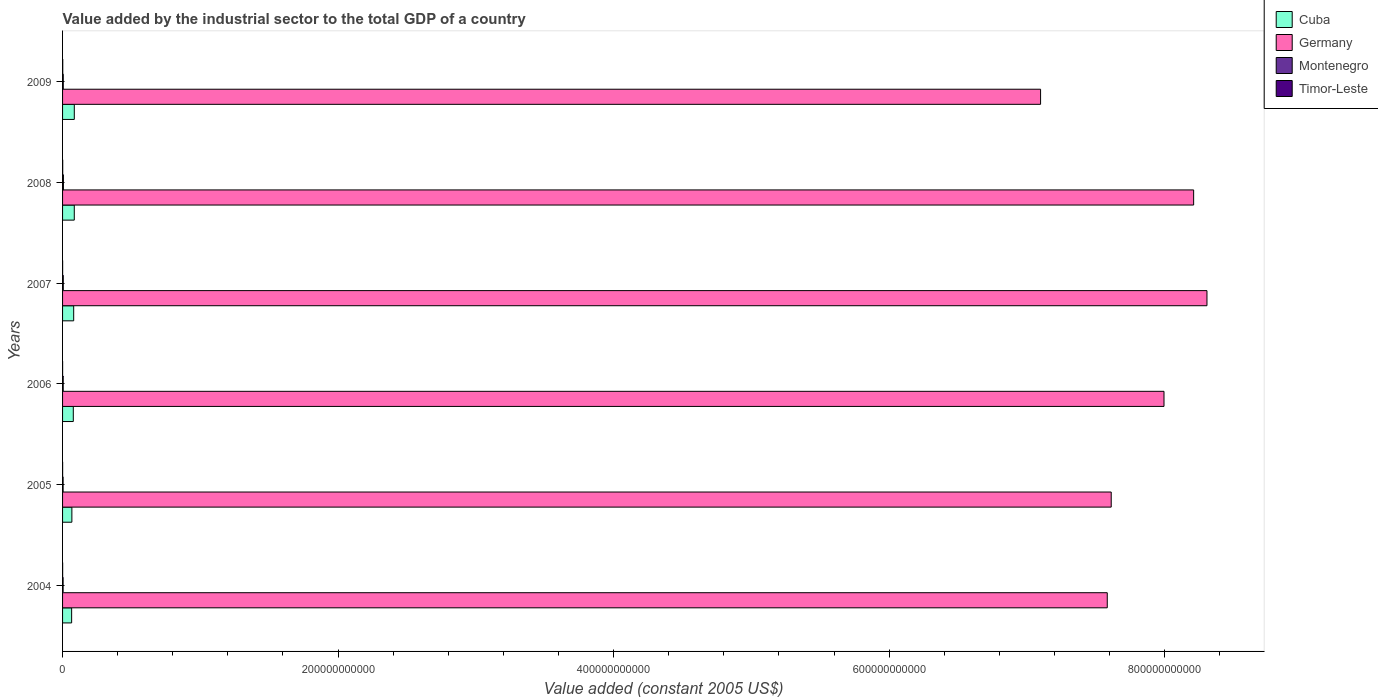How many different coloured bars are there?
Your response must be concise. 4. How many groups of bars are there?
Offer a terse response. 6. Are the number of bars per tick equal to the number of legend labels?
Offer a very short reply. Yes. Are the number of bars on each tick of the Y-axis equal?
Make the answer very short. Yes. How many bars are there on the 5th tick from the bottom?
Provide a short and direct response. 4. What is the label of the 6th group of bars from the top?
Provide a succinct answer. 2004. In how many cases, is the number of bars for a given year not equal to the number of legend labels?
Provide a succinct answer. 0. What is the value added by the industrial sector in Timor-Leste in 2004?
Make the answer very short. 4.95e+07. Across all years, what is the maximum value added by the industrial sector in Germany?
Offer a very short reply. 8.31e+11. Across all years, what is the minimum value added by the industrial sector in Montenegro?
Make the answer very short. 3.91e+08. In which year was the value added by the industrial sector in Montenegro maximum?
Offer a terse response. 2008. What is the total value added by the industrial sector in Timor-Leste in the graph?
Your response must be concise. 4.00e+08. What is the difference between the value added by the industrial sector in Montenegro in 2005 and that in 2009?
Keep it short and to the point. -1.17e+08. What is the difference between the value added by the industrial sector in Germany in 2006 and the value added by the industrial sector in Timor-Leste in 2007?
Give a very brief answer. 7.99e+11. What is the average value added by the industrial sector in Germany per year?
Offer a terse response. 7.80e+11. In the year 2005, what is the difference between the value added by the industrial sector in Germany and value added by the industrial sector in Montenegro?
Your answer should be compact. 7.61e+11. What is the ratio of the value added by the industrial sector in Germany in 2005 to that in 2007?
Your answer should be compact. 0.92. Is the difference between the value added by the industrial sector in Germany in 2005 and 2006 greater than the difference between the value added by the industrial sector in Montenegro in 2005 and 2006?
Your answer should be compact. No. What is the difference between the highest and the second highest value added by the industrial sector in Montenegro?
Offer a very short reply. 1.05e+08. What is the difference between the highest and the lowest value added by the industrial sector in Cuba?
Your response must be concise. 1.93e+09. In how many years, is the value added by the industrial sector in Timor-Leste greater than the average value added by the industrial sector in Timor-Leste taken over all years?
Make the answer very short. 2. What does the 3rd bar from the top in 2005 represents?
Your answer should be compact. Germany. Is it the case that in every year, the sum of the value added by the industrial sector in Germany and value added by the industrial sector in Cuba is greater than the value added by the industrial sector in Montenegro?
Keep it short and to the point. Yes. How many bars are there?
Keep it short and to the point. 24. Are all the bars in the graph horizontal?
Give a very brief answer. Yes. What is the difference between two consecutive major ticks on the X-axis?
Your answer should be very brief. 2.00e+11. Are the values on the major ticks of X-axis written in scientific E-notation?
Make the answer very short. No. Where does the legend appear in the graph?
Your answer should be compact. Top right. How are the legend labels stacked?
Provide a short and direct response. Vertical. What is the title of the graph?
Make the answer very short. Value added by the industrial sector to the total GDP of a country. Does "Tuvalu" appear as one of the legend labels in the graph?
Give a very brief answer. No. What is the label or title of the X-axis?
Your response must be concise. Value added (constant 2005 US$). What is the Value added (constant 2005 US$) in Cuba in 2004?
Your answer should be very brief. 6.58e+09. What is the Value added (constant 2005 US$) of Germany in 2004?
Provide a short and direct response. 7.58e+11. What is the Value added (constant 2005 US$) of Montenegro in 2004?
Provide a short and direct response. 3.91e+08. What is the Value added (constant 2005 US$) of Timor-Leste in 2004?
Your response must be concise. 4.95e+07. What is the Value added (constant 2005 US$) of Cuba in 2005?
Make the answer very short. 6.76e+09. What is the Value added (constant 2005 US$) of Germany in 2005?
Give a very brief answer. 7.61e+11. What is the Value added (constant 2005 US$) in Montenegro in 2005?
Provide a succinct answer. 3.91e+08. What is the Value added (constant 2005 US$) in Timor-Leste in 2005?
Keep it short and to the point. 4.70e+07. What is the Value added (constant 2005 US$) of Cuba in 2006?
Provide a succinct answer. 7.79e+09. What is the Value added (constant 2005 US$) in Germany in 2006?
Keep it short and to the point. 8.00e+11. What is the Value added (constant 2005 US$) in Montenegro in 2006?
Provide a short and direct response. 4.67e+08. What is the Value added (constant 2005 US$) of Timor-Leste in 2006?
Give a very brief answer. 3.11e+07. What is the Value added (constant 2005 US$) of Cuba in 2007?
Your answer should be compact. 8.07e+09. What is the Value added (constant 2005 US$) of Germany in 2007?
Your answer should be very brief. 8.31e+11. What is the Value added (constant 2005 US$) in Montenegro in 2007?
Keep it short and to the point. 5.16e+08. What is the Value added (constant 2005 US$) in Timor-Leste in 2007?
Provide a succinct answer. 4.62e+07. What is the Value added (constant 2005 US$) in Cuba in 2008?
Your answer should be very brief. 8.51e+09. What is the Value added (constant 2005 US$) in Germany in 2008?
Make the answer very short. 8.21e+11. What is the Value added (constant 2005 US$) in Montenegro in 2008?
Provide a succinct answer. 6.22e+08. What is the Value added (constant 2005 US$) of Timor-Leste in 2008?
Offer a terse response. 9.40e+07. What is the Value added (constant 2005 US$) in Cuba in 2009?
Your answer should be very brief. 8.51e+09. What is the Value added (constant 2005 US$) in Germany in 2009?
Your answer should be compact. 7.10e+11. What is the Value added (constant 2005 US$) of Montenegro in 2009?
Offer a very short reply. 5.08e+08. What is the Value added (constant 2005 US$) of Timor-Leste in 2009?
Keep it short and to the point. 1.33e+08. Across all years, what is the maximum Value added (constant 2005 US$) in Cuba?
Keep it short and to the point. 8.51e+09. Across all years, what is the maximum Value added (constant 2005 US$) in Germany?
Ensure brevity in your answer.  8.31e+11. Across all years, what is the maximum Value added (constant 2005 US$) of Montenegro?
Your response must be concise. 6.22e+08. Across all years, what is the maximum Value added (constant 2005 US$) in Timor-Leste?
Give a very brief answer. 1.33e+08. Across all years, what is the minimum Value added (constant 2005 US$) of Cuba?
Provide a short and direct response. 6.58e+09. Across all years, what is the minimum Value added (constant 2005 US$) in Germany?
Ensure brevity in your answer.  7.10e+11. Across all years, what is the minimum Value added (constant 2005 US$) in Montenegro?
Your response must be concise. 3.91e+08. Across all years, what is the minimum Value added (constant 2005 US$) in Timor-Leste?
Offer a terse response. 3.11e+07. What is the total Value added (constant 2005 US$) in Cuba in the graph?
Your response must be concise. 4.62e+1. What is the total Value added (constant 2005 US$) of Germany in the graph?
Give a very brief answer. 4.68e+12. What is the total Value added (constant 2005 US$) of Montenegro in the graph?
Provide a short and direct response. 2.90e+09. What is the total Value added (constant 2005 US$) in Timor-Leste in the graph?
Your answer should be compact. 4.00e+08. What is the difference between the Value added (constant 2005 US$) in Cuba in 2004 and that in 2005?
Your response must be concise. -1.77e+08. What is the difference between the Value added (constant 2005 US$) in Germany in 2004 and that in 2005?
Give a very brief answer. -2.87e+09. What is the difference between the Value added (constant 2005 US$) of Montenegro in 2004 and that in 2005?
Offer a terse response. -6.68e+05. What is the difference between the Value added (constant 2005 US$) of Timor-Leste in 2004 and that in 2005?
Offer a very short reply. 2.52e+06. What is the difference between the Value added (constant 2005 US$) of Cuba in 2004 and that in 2006?
Your answer should be compact. -1.20e+09. What is the difference between the Value added (constant 2005 US$) of Germany in 2004 and that in 2006?
Provide a short and direct response. -4.12e+1. What is the difference between the Value added (constant 2005 US$) in Montenegro in 2004 and that in 2006?
Ensure brevity in your answer.  -7.62e+07. What is the difference between the Value added (constant 2005 US$) in Timor-Leste in 2004 and that in 2006?
Offer a very short reply. 1.85e+07. What is the difference between the Value added (constant 2005 US$) in Cuba in 2004 and that in 2007?
Your answer should be very brief. -1.49e+09. What is the difference between the Value added (constant 2005 US$) in Germany in 2004 and that in 2007?
Ensure brevity in your answer.  -7.24e+1. What is the difference between the Value added (constant 2005 US$) of Montenegro in 2004 and that in 2007?
Your answer should be very brief. -1.26e+08. What is the difference between the Value added (constant 2005 US$) of Timor-Leste in 2004 and that in 2007?
Your answer should be compact. 3.36e+06. What is the difference between the Value added (constant 2005 US$) in Cuba in 2004 and that in 2008?
Provide a short and direct response. -1.92e+09. What is the difference between the Value added (constant 2005 US$) of Germany in 2004 and that in 2008?
Make the answer very short. -6.27e+1. What is the difference between the Value added (constant 2005 US$) in Montenegro in 2004 and that in 2008?
Give a very brief answer. -2.31e+08. What is the difference between the Value added (constant 2005 US$) of Timor-Leste in 2004 and that in 2008?
Make the answer very short. -4.45e+07. What is the difference between the Value added (constant 2005 US$) in Cuba in 2004 and that in 2009?
Keep it short and to the point. -1.93e+09. What is the difference between the Value added (constant 2005 US$) in Germany in 2004 and that in 2009?
Your answer should be compact. 4.84e+1. What is the difference between the Value added (constant 2005 US$) in Montenegro in 2004 and that in 2009?
Give a very brief answer. -1.17e+08. What is the difference between the Value added (constant 2005 US$) in Timor-Leste in 2004 and that in 2009?
Provide a short and direct response. -8.31e+07. What is the difference between the Value added (constant 2005 US$) in Cuba in 2005 and that in 2006?
Make the answer very short. -1.03e+09. What is the difference between the Value added (constant 2005 US$) in Germany in 2005 and that in 2006?
Give a very brief answer. -3.83e+1. What is the difference between the Value added (constant 2005 US$) of Montenegro in 2005 and that in 2006?
Your response must be concise. -7.56e+07. What is the difference between the Value added (constant 2005 US$) in Timor-Leste in 2005 and that in 2006?
Make the answer very short. 1.59e+07. What is the difference between the Value added (constant 2005 US$) of Cuba in 2005 and that in 2007?
Give a very brief answer. -1.31e+09. What is the difference between the Value added (constant 2005 US$) of Germany in 2005 and that in 2007?
Your answer should be compact. -6.95e+1. What is the difference between the Value added (constant 2005 US$) of Montenegro in 2005 and that in 2007?
Your answer should be compact. -1.25e+08. What is the difference between the Value added (constant 2005 US$) in Timor-Leste in 2005 and that in 2007?
Offer a very short reply. 8.39e+05. What is the difference between the Value added (constant 2005 US$) in Cuba in 2005 and that in 2008?
Ensure brevity in your answer.  -1.74e+09. What is the difference between the Value added (constant 2005 US$) in Germany in 2005 and that in 2008?
Your response must be concise. -5.98e+1. What is the difference between the Value added (constant 2005 US$) in Montenegro in 2005 and that in 2008?
Offer a terse response. -2.30e+08. What is the difference between the Value added (constant 2005 US$) of Timor-Leste in 2005 and that in 2008?
Ensure brevity in your answer.  -4.70e+07. What is the difference between the Value added (constant 2005 US$) in Cuba in 2005 and that in 2009?
Offer a terse response. -1.75e+09. What is the difference between the Value added (constant 2005 US$) in Germany in 2005 and that in 2009?
Offer a terse response. 5.13e+1. What is the difference between the Value added (constant 2005 US$) of Montenegro in 2005 and that in 2009?
Offer a very short reply. -1.17e+08. What is the difference between the Value added (constant 2005 US$) in Timor-Leste in 2005 and that in 2009?
Make the answer very short. -8.56e+07. What is the difference between the Value added (constant 2005 US$) of Cuba in 2006 and that in 2007?
Offer a terse response. -2.87e+08. What is the difference between the Value added (constant 2005 US$) of Germany in 2006 and that in 2007?
Your answer should be very brief. -3.12e+1. What is the difference between the Value added (constant 2005 US$) in Montenegro in 2006 and that in 2007?
Offer a terse response. -4.94e+07. What is the difference between the Value added (constant 2005 US$) of Timor-Leste in 2006 and that in 2007?
Provide a short and direct response. -1.51e+07. What is the difference between the Value added (constant 2005 US$) in Cuba in 2006 and that in 2008?
Your answer should be very brief. -7.19e+08. What is the difference between the Value added (constant 2005 US$) in Germany in 2006 and that in 2008?
Your answer should be compact. -2.15e+1. What is the difference between the Value added (constant 2005 US$) in Montenegro in 2006 and that in 2008?
Your answer should be compact. -1.55e+08. What is the difference between the Value added (constant 2005 US$) in Timor-Leste in 2006 and that in 2008?
Give a very brief answer. -6.29e+07. What is the difference between the Value added (constant 2005 US$) of Cuba in 2006 and that in 2009?
Offer a terse response. -7.25e+08. What is the difference between the Value added (constant 2005 US$) of Germany in 2006 and that in 2009?
Offer a terse response. 8.96e+1. What is the difference between the Value added (constant 2005 US$) of Montenegro in 2006 and that in 2009?
Give a very brief answer. -4.11e+07. What is the difference between the Value added (constant 2005 US$) in Timor-Leste in 2006 and that in 2009?
Your answer should be compact. -1.02e+08. What is the difference between the Value added (constant 2005 US$) in Cuba in 2007 and that in 2008?
Offer a very short reply. -4.32e+08. What is the difference between the Value added (constant 2005 US$) in Germany in 2007 and that in 2008?
Your answer should be compact. 9.68e+09. What is the difference between the Value added (constant 2005 US$) in Montenegro in 2007 and that in 2008?
Give a very brief answer. -1.05e+08. What is the difference between the Value added (constant 2005 US$) of Timor-Leste in 2007 and that in 2008?
Offer a very short reply. -4.78e+07. What is the difference between the Value added (constant 2005 US$) in Cuba in 2007 and that in 2009?
Your answer should be very brief. -4.38e+08. What is the difference between the Value added (constant 2005 US$) of Germany in 2007 and that in 2009?
Ensure brevity in your answer.  1.21e+11. What is the difference between the Value added (constant 2005 US$) in Montenegro in 2007 and that in 2009?
Ensure brevity in your answer.  8.24e+06. What is the difference between the Value added (constant 2005 US$) of Timor-Leste in 2007 and that in 2009?
Your answer should be compact. -8.64e+07. What is the difference between the Value added (constant 2005 US$) of Cuba in 2008 and that in 2009?
Keep it short and to the point. -5.67e+06. What is the difference between the Value added (constant 2005 US$) of Germany in 2008 and that in 2009?
Provide a short and direct response. 1.11e+11. What is the difference between the Value added (constant 2005 US$) of Montenegro in 2008 and that in 2009?
Your response must be concise. 1.14e+08. What is the difference between the Value added (constant 2005 US$) of Timor-Leste in 2008 and that in 2009?
Make the answer very short. -3.86e+07. What is the difference between the Value added (constant 2005 US$) of Cuba in 2004 and the Value added (constant 2005 US$) of Germany in 2005?
Make the answer very short. -7.55e+11. What is the difference between the Value added (constant 2005 US$) in Cuba in 2004 and the Value added (constant 2005 US$) in Montenegro in 2005?
Make the answer very short. 6.19e+09. What is the difference between the Value added (constant 2005 US$) of Cuba in 2004 and the Value added (constant 2005 US$) of Timor-Leste in 2005?
Ensure brevity in your answer.  6.54e+09. What is the difference between the Value added (constant 2005 US$) in Germany in 2004 and the Value added (constant 2005 US$) in Montenegro in 2005?
Provide a succinct answer. 7.58e+11. What is the difference between the Value added (constant 2005 US$) in Germany in 2004 and the Value added (constant 2005 US$) in Timor-Leste in 2005?
Your answer should be very brief. 7.58e+11. What is the difference between the Value added (constant 2005 US$) in Montenegro in 2004 and the Value added (constant 2005 US$) in Timor-Leste in 2005?
Keep it short and to the point. 3.44e+08. What is the difference between the Value added (constant 2005 US$) of Cuba in 2004 and the Value added (constant 2005 US$) of Germany in 2006?
Offer a very short reply. -7.93e+11. What is the difference between the Value added (constant 2005 US$) of Cuba in 2004 and the Value added (constant 2005 US$) of Montenegro in 2006?
Keep it short and to the point. 6.12e+09. What is the difference between the Value added (constant 2005 US$) of Cuba in 2004 and the Value added (constant 2005 US$) of Timor-Leste in 2006?
Give a very brief answer. 6.55e+09. What is the difference between the Value added (constant 2005 US$) in Germany in 2004 and the Value added (constant 2005 US$) in Montenegro in 2006?
Your answer should be compact. 7.58e+11. What is the difference between the Value added (constant 2005 US$) of Germany in 2004 and the Value added (constant 2005 US$) of Timor-Leste in 2006?
Ensure brevity in your answer.  7.58e+11. What is the difference between the Value added (constant 2005 US$) of Montenegro in 2004 and the Value added (constant 2005 US$) of Timor-Leste in 2006?
Your answer should be very brief. 3.60e+08. What is the difference between the Value added (constant 2005 US$) in Cuba in 2004 and the Value added (constant 2005 US$) in Germany in 2007?
Provide a succinct answer. -8.24e+11. What is the difference between the Value added (constant 2005 US$) of Cuba in 2004 and the Value added (constant 2005 US$) of Montenegro in 2007?
Ensure brevity in your answer.  6.07e+09. What is the difference between the Value added (constant 2005 US$) of Cuba in 2004 and the Value added (constant 2005 US$) of Timor-Leste in 2007?
Keep it short and to the point. 6.54e+09. What is the difference between the Value added (constant 2005 US$) of Germany in 2004 and the Value added (constant 2005 US$) of Montenegro in 2007?
Make the answer very short. 7.58e+11. What is the difference between the Value added (constant 2005 US$) of Germany in 2004 and the Value added (constant 2005 US$) of Timor-Leste in 2007?
Provide a short and direct response. 7.58e+11. What is the difference between the Value added (constant 2005 US$) of Montenegro in 2004 and the Value added (constant 2005 US$) of Timor-Leste in 2007?
Offer a terse response. 3.45e+08. What is the difference between the Value added (constant 2005 US$) in Cuba in 2004 and the Value added (constant 2005 US$) in Germany in 2008?
Your answer should be compact. -8.14e+11. What is the difference between the Value added (constant 2005 US$) in Cuba in 2004 and the Value added (constant 2005 US$) in Montenegro in 2008?
Your answer should be very brief. 5.96e+09. What is the difference between the Value added (constant 2005 US$) of Cuba in 2004 and the Value added (constant 2005 US$) of Timor-Leste in 2008?
Your response must be concise. 6.49e+09. What is the difference between the Value added (constant 2005 US$) in Germany in 2004 and the Value added (constant 2005 US$) in Montenegro in 2008?
Your response must be concise. 7.58e+11. What is the difference between the Value added (constant 2005 US$) of Germany in 2004 and the Value added (constant 2005 US$) of Timor-Leste in 2008?
Offer a terse response. 7.58e+11. What is the difference between the Value added (constant 2005 US$) in Montenegro in 2004 and the Value added (constant 2005 US$) in Timor-Leste in 2008?
Provide a short and direct response. 2.97e+08. What is the difference between the Value added (constant 2005 US$) of Cuba in 2004 and the Value added (constant 2005 US$) of Germany in 2009?
Provide a short and direct response. -7.03e+11. What is the difference between the Value added (constant 2005 US$) in Cuba in 2004 and the Value added (constant 2005 US$) in Montenegro in 2009?
Keep it short and to the point. 6.08e+09. What is the difference between the Value added (constant 2005 US$) of Cuba in 2004 and the Value added (constant 2005 US$) of Timor-Leste in 2009?
Provide a short and direct response. 6.45e+09. What is the difference between the Value added (constant 2005 US$) in Germany in 2004 and the Value added (constant 2005 US$) in Montenegro in 2009?
Keep it short and to the point. 7.58e+11. What is the difference between the Value added (constant 2005 US$) of Germany in 2004 and the Value added (constant 2005 US$) of Timor-Leste in 2009?
Your answer should be very brief. 7.58e+11. What is the difference between the Value added (constant 2005 US$) in Montenegro in 2004 and the Value added (constant 2005 US$) in Timor-Leste in 2009?
Your answer should be very brief. 2.58e+08. What is the difference between the Value added (constant 2005 US$) of Cuba in 2005 and the Value added (constant 2005 US$) of Germany in 2006?
Provide a succinct answer. -7.93e+11. What is the difference between the Value added (constant 2005 US$) of Cuba in 2005 and the Value added (constant 2005 US$) of Montenegro in 2006?
Your answer should be compact. 6.29e+09. What is the difference between the Value added (constant 2005 US$) of Cuba in 2005 and the Value added (constant 2005 US$) of Timor-Leste in 2006?
Your response must be concise. 6.73e+09. What is the difference between the Value added (constant 2005 US$) in Germany in 2005 and the Value added (constant 2005 US$) in Montenegro in 2006?
Provide a short and direct response. 7.61e+11. What is the difference between the Value added (constant 2005 US$) in Germany in 2005 and the Value added (constant 2005 US$) in Timor-Leste in 2006?
Your response must be concise. 7.61e+11. What is the difference between the Value added (constant 2005 US$) in Montenegro in 2005 and the Value added (constant 2005 US$) in Timor-Leste in 2006?
Provide a short and direct response. 3.60e+08. What is the difference between the Value added (constant 2005 US$) in Cuba in 2005 and the Value added (constant 2005 US$) in Germany in 2007?
Offer a terse response. -8.24e+11. What is the difference between the Value added (constant 2005 US$) of Cuba in 2005 and the Value added (constant 2005 US$) of Montenegro in 2007?
Your answer should be very brief. 6.25e+09. What is the difference between the Value added (constant 2005 US$) in Cuba in 2005 and the Value added (constant 2005 US$) in Timor-Leste in 2007?
Your answer should be very brief. 6.72e+09. What is the difference between the Value added (constant 2005 US$) in Germany in 2005 and the Value added (constant 2005 US$) in Montenegro in 2007?
Your answer should be very brief. 7.61e+11. What is the difference between the Value added (constant 2005 US$) of Germany in 2005 and the Value added (constant 2005 US$) of Timor-Leste in 2007?
Offer a terse response. 7.61e+11. What is the difference between the Value added (constant 2005 US$) in Montenegro in 2005 and the Value added (constant 2005 US$) in Timor-Leste in 2007?
Your response must be concise. 3.45e+08. What is the difference between the Value added (constant 2005 US$) in Cuba in 2005 and the Value added (constant 2005 US$) in Germany in 2008?
Offer a very short reply. -8.14e+11. What is the difference between the Value added (constant 2005 US$) in Cuba in 2005 and the Value added (constant 2005 US$) in Montenegro in 2008?
Provide a short and direct response. 6.14e+09. What is the difference between the Value added (constant 2005 US$) in Cuba in 2005 and the Value added (constant 2005 US$) in Timor-Leste in 2008?
Make the answer very short. 6.67e+09. What is the difference between the Value added (constant 2005 US$) of Germany in 2005 and the Value added (constant 2005 US$) of Montenegro in 2008?
Give a very brief answer. 7.61e+11. What is the difference between the Value added (constant 2005 US$) of Germany in 2005 and the Value added (constant 2005 US$) of Timor-Leste in 2008?
Keep it short and to the point. 7.61e+11. What is the difference between the Value added (constant 2005 US$) of Montenegro in 2005 and the Value added (constant 2005 US$) of Timor-Leste in 2008?
Ensure brevity in your answer.  2.97e+08. What is the difference between the Value added (constant 2005 US$) in Cuba in 2005 and the Value added (constant 2005 US$) in Germany in 2009?
Your answer should be very brief. -7.03e+11. What is the difference between the Value added (constant 2005 US$) in Cuba in 2005 and the Value added (constant 2005 US$) in Montenegro in 2009?
Your answer should be very brief. 6.25e+09. What is the difference between the Value added (constant 2005 US$) of Cuba in 2005 and the Value added (constant 2005 US$) of Timor-Leste in 2009?
Your answer should be compact. 6.63e+09. What is the difference between the Value added (constant 2005 US$) in Germany in 2005 and the Value added (constant 2005 US$) in Montenegro in 2009?
Your answer should be very brief. 7.61e+11. What is the difference between the Value added (constant 2005 US$) in Germany in 2005 and the Value added (constant 2005 US$) in Timor-Leste in 2009?
Offer a terse response. 7.61e+11. What is the difference between the Value added (constant 2005 US$) in Montenegro in 2005 and the Value added (constant 2005 US$) in Timor-Leste in 2009?
Keep it short and to the point. 2.59e+08. What is the difference between the Value added (constant 2005 US$) in Cuba in 2006 and the Value added (constant 2005 US$) in Germany in 2007?
Your answer should be compact. -8.23e+11. What is the difference between the Value added (constant 2005 US$) of Cuba in 2006 and the Value added (constant 2005 US$) of Montenegro in 2007?
Your response must be concise. 7.27e+09. What is the difference between the Value added (constant 2005 US$) in Cuba in 2006 and the Value added (constant 2005 US$) in Timor-Leste in 2007?
Provide a short and direct response. 7.74e+09. What is the difference between the Value added (constant 2005 US$) in Germany in 2006 and the Value added (constant 2005 US$) in Montenegro in 2007?
Your response must be concise. 7.99e+11. What is the difference between the Value added (constant 2005 US$) in Germany in 2006 and the Value added (constant 2005 US$) in Timor-Leste in 2007?
Your answer should be very brief. 7.99e+11. What is the difference between the Value added (constant 2005 US$) of Montenegro in 2006 and the Value added (constant 2005 US$) of Timor-Leste in 2007?
Ensure brevity in your answer.  4.21e+08. What is the difference between the Value added (constant 2005 US$) in Cuba in 2006 and the Value added (constant 2005 US$) in Germany in 2008?
Give a very brief answer. -8.13e+11. What is the difference between the Value added (constant 2005 US$) of Cuba in 2006 and the Value added (constant 2005 US$) of Montenegro in 2008?
Keep it short and to the point. 7.17e+09. What is the difference between the Value added (constant 2005 US$) of Cuba in 2006 and the Value added (constant 2005 US$) of Timor-Leste in 2008?
Your answer should be compact. 7.69e+09. What is the difference between the Value added (constant 2005 US$) of Germany in 2006 and the Value added (constant 2005 US$) of Montenegro in 2008?
Provide a short and direct response. 7.99e+11. What is the difference between the Value added (constant 2005 US$) in Germany in 2006 and the Value added (constant 2005 US$) in Timor-Leste in 2008?
Offer a terse response. 7.99e+11. What is the difference between the Value added (constant 2005 US$) in Montenegro in 2006 and the Value added (constant 2005 US$) in Timor-Leste in 2008?
Keep it short and to the point. 3.73e+08. What is the difference between the Value added (constant 2005 US$) of Cuba in 2006 and the Value added (constant 2005 US$) of Germany in 2009?
Give a very brief answer. -7.02e+11. What is the difference between the Value added (constant 2005 US$) in Cuba in 2006 and the Value added (constant 2005 US$) in Montenegro in 2009?
Provide a succinct answer. 7.28e+09. What is the difference between the Value added (constant 2005 US$) of Cuba in 2006 and the Value added (constant 2005 US$) of Timor-Leste in 2009?
Your answer should be very brief. 7.65e+09. What is the difference between the Value added (constant 2005 US$) of Germany in 2006 and the Value added (constant 2005 US$) of Montenegro in 2009?
Your answer should be very brief. 7.99e+11. What is the difference between the Value added (constant 2005 US$) in Germany in 2006 and the Value added (constant 2005 US$) in Timor-Leste in 2009?
Your answer should be very brief. 7.99e+11. What is the difference between the Value added (constant 2005 US$) in Montenegro in 2006 and the Value added (constant 2005 US$) in Timor-Leste in 2009?
Provide a succinct answer. 3.34e+08. What is the difference between the Value added (constant 2005 US$) of Cuba in 2007 and the Value added (constant 2005 US$) of Germany in 2008?
Offer a terse response. -8.13e+11. What is the difference between the Value added (constant 2005 US$) of Cuba in 2007 and the Value added (constant 2005 US$) of Montenegro in 2008?
Your response must be concise. 7.45e+09. What is the difference between the Value added (constant 2005 US$) of Cuba in 2007 and the Value added (constant 2005 US$) of Timor-Leste in 2008?
Make the answer very short. 7.98e+09. What is the difference between the Value added (constant 2005 US$) of Germany in 2007 and the Value added (constant 2005 US$) of Montenegro in 2008?
Your response must be concise. 8.30e+11. What is the difference between the Value added (constant 2005 US$) in Germany in 2007 and the Value added (constant 2005 US$) in Timor-Leste in 2008?
Your answer should be compact. 8.31e+11. What is the difference between the Value added (constant 2005 US$) in Montenegro in 2007 and the Value added (constant 2005 US$) in Timor-Leste in 2008?
Offer a terse response. 4.22e+08. What is the difference between the Value added (constant 2005 US$) of Cuba in 2007 and the Value added (constant 2005 US$) of Germany in 2009?
Give a very brief answer. -7.02e+11. What is the difference between the Value added (constant 2005 US$) of Cuba in 2007 and the Value added (constant 2005 US$) of Montenegro in 2009?
Your response must be concise. 7.57e+09. What is the difference between the Value added (constant 2005 US$) of Cuba in 2007 and the Value added (constant 2005 US$) of Timor-Leste in 2009?
Offer a very short reply. 7.94e+09. What is the difference between the Value added (constant 2005 US$) of Germany in 2007 and the Value added (constant 2005 US$) of Montenegro in 2009?
Ensure brevity in your answer.  8.30e+11. What is the difference between the Value added (constant 2005 US$) in Germany in 2007 and the Value added (constant 2005 US$) in Timor-Leste in 2009?
Ensure brevity in your answer.  8.31e+11. What is the difference between the Value added (constant 2005 US$) of Montenegro in 2007 and the Value added (constant 2005 US$) of Timor-Leste in 2009?
Offer a very short reply. 3.84e+08. What is the difference between the Value added (constant 2005 US$) in Cuba in 2008 and the Value added (constant 2005 US$) in Germany in 2009?
Make the answer very short. -7.01e+11. What is the difference between the Value added (constant 2005 US$) in Cuba in 2008 and the Value added (constant 2005 US$) in Montenegro in 2009?
Give a very brief answer. 8.00e+09. What is the difference between the Value added (constant 2005 US$) in Cuba in 2008 and the Value added (constant 2005 US$) in Timor-Leste in 2009?
Keep it short and to the point. 8.37e+09. What is the difference between the Value added (constant 2005 US$) in Germany in 2008 and the Value added (constant 2005 US$) in Montenegro in 2009?
Keep it short and to the point. 8.21e+11. What is the difference between the Value added (constant 2005 US$) of Germany in 2008 and the Value added (constant 2005 US$) of Timor-Leste in 2009?
Your response must be concise. 8.21e+11. What is the difference between the Value added (constant 2005 US$) in Montenegro in 2008 and the Value added (constant 2005 US$) in Timor-Leste in 2009?
Offer a very short reply. 4.89e+08. What is the average Value added (constant 2005 US$) of Cuba per year?
Provide a succinct answer. 7.70e+09. What is the average Value added (constant 2005 US$) in Germany per year?
Make the answer very short. 7.80e+11. What is the average Value added (constant 2005 US$) of Montenegro per year?
Your answer should be compact. 4.83e+08. What is the average Value added (constant 2005 US$) of Timor-Leste per year?
Provide a short and direct response. 6.67e+07. In the year 2004, what is the difference between the Value added (constant 2005 US$) of Cuba and Value added (constant 2005 US$) of Germany?
Provide a short and direct response. -7.52e+11. In the year 2004, what is the difference between the Value added (constant 2005 US$) of Cuba and Value added (constant 2005 US$) of Montenegro?
Your answer should be compact. 6.19e+09. In the year 2004, what is the difference between the Value added (constant 2005 US$) in Cuba and Value added (constant 2005 US$) in Timor-Leste?
Your answer should be very brief. 6.53e+09. In the year 2004, what is the difference between the Value added (constant 2005 US$) in Germany and Value added (constant 2005 US$) in Montenegro?
Your answer should be compact. 7.58e+11. In the year 2004, what is the difference between the Value added (constant 2005 US$) of Germany and Value added (constant 2005 US$) of Timor-Leste?
Offer a very short reply. 7.58e+11. In the year 2004, what is the difference between the Value added (constant 2005 US$) of Montenegro and Value added (constant 2005 US$) of Timor-Leste?
Offer a terse response. 3.41e+08. In the year 2005, what is the difference between the Value added (constant 2005 US$) in Cuba and Value added (constant 2005 US$) in Germany?
Your answer should be very brief. -7.54e+11. In the year 2005, what is the difference between the Value added (constant 2005 US$) in Cuba and Value added (constant 2005 US$) in Montenegro?
Ensure brevity in your answer.  6.37e+09. In the year 2005, what is the difference between the Value added (constant 2005 US$) of Cuba and Value added (constant 2005 US$) of Timor-Leste?
Your response must be concise. 6.71e+09. In the year 2005, what is the difference between the Value added (constant 2005 US$) in Germany and Value added (constant 2005 US$) in Montenegro?
Provide a succinct answer. 7.61e+11. In the year 2005, what is the difference between the Value added (constant 2005 US$) of Germany and Value added (constant 2005 US$) of Timor-Leste?
Your response must be concise. 7.61e+11. In the year 2005, what is the difference between the Value added (constant 2005 US$) in Montenegro and Value added (constant 2005 US$) in Timor-Leste?
Your answer should be compact. 3.44e+08. In the year 2006, what is the difference between the Value added (constant 2005 US$) of Cuba and Value added (constant 2005 US$) of Germany?
Offer a very short reply. -7.92e+11. In the year 2006, what is the difference between the Value added (constant 2005 US$) in Cuba and Value added (constant 2005 US$) in Montenegro?
Give a very brief answer. 7.32e+09. In the year 2006, what is the difference between the Value added (constant 2005 US$) in Cuba and Value added (constant 2005 US$) in Timor-Leste?
Your answer should be compact. 7.76e+09. In the year 2006, what is the difference between the Value added (constant 2005 US$) in Germany and Value added (constant 2005 US$) in Montenegro?
Offer a very short reply. 7.99e+11. In the year 2006, what is the difference between the Value added (constant 2005 US$) in Germany and Value added (constant 2005 US$) in Timor-Leste?
Offer a very short reply. 7.99e+11. In the year 2006, what is the difference between the Value added (constant 2005 US$) in Montenegro and Value added (constant 2005 US$) in Timor-Leste?
Offer a very short reply. 4.36e+08. In the year 2007, what is the difference between the Value added (constant 2005 US$) in Cuba and Value added (constant 2005 US$) in Germany?
Your answer should be very brief. -8.23e+11. In the year 2007, what is the difference between the Value added (constant 2005 US$) in Cuba and Value added (constant 2005 US$) in Montenegro?
Your response must be concise. 7.56e+09. In the year 2007, what is the difference between the Value added (constant 2005 US$) in Cuba and Value added (constant 2005 US$) in Timor-Leste?
Provide a succinct answer. 8.03e+09. In the year 2007, what is the difference between the Value added (constant 2005 US$) in Germany and Value added (constant 2005 US$) in Montenegro?
Keep it short and to the point. 8.30e+11. In the year 2007, what is the difference between the Value added (constant 2005 US$) of Germany and Value added (constant 2005 US$) of Timor-Leste?
Provide a short and direct response. 8.31e+11. In the year 2007, what is the difference between the Value added (constant 2005 US$) in Montenegro and Value added (constant 2005 US$) in Timor-Leste?
Provide a succinct answer. 4.70e+08. In the year 2008, what is the difference between the Value added (constant 2005 US$) of Cuba and Value added (constant 2005 US$) of Germany?
Keep it short and to the point. -8.13e+11. In the year 2008, what is the difference between the Value added (constant 2005 US$) of Cuba and Value added (constant 2005 US$) of Montenegro?
Give a very brief answer. 7.88e+09. In the year 2008, what is the difference between the Value added (constant 2005 US$) in Cuba and Value added (constant 2005 US$) in Timor-Leste?
Make the answer very short. 8.41e+09. In the year 2008, what is the difference between the Value added (constant 2005 US$) in Germany and Value added (constant 2005 US$) in Montenegro?
Make the answer very short. 8.20e+11. In the year 2008, what is the difference between the Value added (constant 2005 US$) of Germany and Value added (constant 2005 US$) of Timor-Leste?
Make the answer very short. 8.21e+11. In the year 2008, what is the difference between the Value added (constant 2005 US$) of Montenegro and Value added (constant 2005 US$) of Timor-Leste?
Make the answer very short. 5.28e+08. In the year 2009, what is the difference between the Value added (constant 2005 US$) in Cuba and Value added (constant 2005 US$) in Germany?
Give a very brief answer. -7.01e+11. In the year 2009, what is the difference between the Value added (constant 2005 US$) in Cuba and Value added (constant 2005 US$) in Montenegro?
Ensure brevity in your answer.  8.00e+09. In the year 2009, what is the difference between the Value added (constant 2005 US$) in Cuba and Value added (constant 2005 US$) in Timor-Leste?
Give a very brief answer. 8.38e+09. In the year 2009, what is the difference between the Value added (constant 2005 US$) in Germany and Value added (constant 2005 US$) in Montenegro?
Give a very brief answer. 7.09e+11. In the year 2009, what is the difference between the Value added (constant 2005 US$) in Germany and Value added (constant 2005 US$) in Timor-Leste?
Provide a succinct answer. 7.10e+11. In the year 2009, what is the difference between the Value added (constant 2005 US$) of Montenegro and Value added (constant 2005 US$) of Timor-Leste?
Ensure brevity in your answer.  3.75e+08. What is the ratio of the Value added (constant 2005 US$) of Cuba in 2004 to that in 2005?
Your answer should be very brief. 0.97. What is the ratio of the Value added (constant 2005 US$) in Timor-Leste in 2004 to that in 2005?
Offer a very short reply. 1.05. What is the ratio of the Value added (constant 2005 US$) in Cuba in 2004 to that in 2006?
Your response must be concise. 0.85. What is the ratio of the Value added (constant 2005 US$) of Germany in 2004 to that in 2006?
Ensure brevity in your answer.  0.95. What is the ratio of the Value added (constant 2005 US$) of Montenegro in 2004 to that in 2006?
Your response must be concise. 0.84. What is the ratio of the Value added (constant 2005 US$) of Timor-Leste in 2004 to that in 2006?
Offer a terse response. 1.59. What is the ratio of the Value added (constant 2005 US$) of Cuba in 2004 to that in 2007?
Offer a very short reply. 0.82. What is the ratio of the Value added (constant 2005 US$) of Germany in 2004 to that in 2007?
Offer a very short reply. 0.91. What is the ratio of the Value added (constant 2005 US$) of Montenegro in 2004 to that in 2007?
Ensure brevity in your answer.  0.76. What is the ratio of the Value added (constant 2005 US$) in Timor-Leste in 2004 to that in 2007?
Ensure brevity in your answer.  1.07. What is the ratio of the Value added (constant 2005 US$) in Cuba in 2004 to that in 2008?
Your answer should be very brief. 0.77. What is the ratio of the Value added (constant 2005 US$) of Germany in 2004 to that in 2008?
Give a very brief answer. 0.92. What is the ratio of the Value added (constant 2005 US$) of Montenegro in 2004 to that in 2008?
Provide a short and direct response. 0.63. What is the ratio of the Value added (constant 2005 US$) of Timor-Leste in 2004 to that in 2008?
Ensure brevity in your answer.  0.53. What is the ratio of the Value added (constant 2005 US$) of Cuba in 2004 to that in 2009?
Offer a terse response. 0.77. What is the ratio of the Value added (constant 2005 US$) of Germany in 2004 to that in 2009?
Your answer should be compact. 1.07. What is the ratio of the Value added (constant 2005 US$) of Montenegro in 2004 to that in 2009?
Keep it short and to the point. 0.77. What is the ratio of the Value added (constant 2005 US$) of Timor-Leste in 2004 to that in 2009?
Offer a very short reply. 0.37. What is the ratio of the Value added (constant 2005 US$) of Cuba in 2005 to that in 2006?
Make the answer very short. 0.87. What is the ratio of the Value added (constant 2005 US$) of Germany in 2005 to that in 2006?
Offer a terse response. 0.95. What is the ratio of the Value added (constant 2005 US$) in Montenegro in 2005 to that in 2006?
Provide a short and direct response. 0.84. What is the ratio of the Value added (constant 2005 US$) in Timor-Leste in 2005 to that in 2006?
Your answer should be very brief. 1.51. What is the ratio of the Value added (constant 2005 US$) of Cuba in 2005 to that in 2007?
Keep it short and to the point. 0.84. What is the ratio of the Value added (constant 2005 US$) of Germany in 2005 to that in 2007?
Your answer should be very brief. 0.92. What is the ratio of the Value added (constant 2005 US$) in Montenegro in 2005 to that in 2007?
Your answer should be compact. 0.76. What is the ratio of the Value added (constant 2005 US$) of Timor-Leste in 2005 to that in 2007?
Your answer should be very brief. 1.02. What is the ratio of the Value added (constant 2005 US$) of Cuba in 2005 to that in 2008?
Your answer should be very brief. 0.79. What is the ratio of the Value added (constant 2005 US$) of Germany in 2005 to that in 2008?
Make the answer very short. 0.93. What is the ratio of the Value added (constant 2005 US$) in Montenegro in 2005 to that in 2008?
Your response must be concise. 0.63. What is the ratio of the Value added (constant 2005 US$) in Timor-Leste in 2005 to that in 2008?
Your response must be concise. 0.5. What is the ratio of the Value added (constant 2005 US$) of Cuba in 2005 to that in 2009?
Offer a terse response. 0.79. What is the ratio of the Value added (constant 2005 US$) in Germany in 2005 to that in 2009?
Your response must be concise. 1.07. What is the ratio of the Value added (constant 2005 US$) of Montenegro in 2005 to that in 2009?
Offer a very short reply. 0.77. What is the ratio of the Value added (constant 2005 US$) in Timor-Leste in 2005 to that in 2009?
Offer a very short reply. 0.35. What is the ratio of the Value added (constant 2005 US$) of Cuba in 2006 to that in 2007?
Ensure brevity in your answer.  0.96. What is the ratio of the Value added (constant 2005 US$) in Germany in 2006 to that in 2007?
Provide a succinct answer. 0.96. What is the ratio of the Value added (constant 2005 US$) in Montenegro in 2006 to that in 2007?
Keep it short and to the point. 0.9. What is the ratio of the Value added (constant 2005 US$) of Timor-Leste in 2006 to that in 2007?
Your response must be concise. 0.67. What is the ratio of the Value added (constant 2005 US$) of Cuba in 2006 to that in 2008?
Your answer should be compact. 0.92. What is the ratio of the Value added (constant 2005 US$) in Germany in 2006 to that in 2008?
Keep it short and to the point. 0.97. What is the ratio of the Value added (constant 2005 US$) of Montenegro in 2006 to that in 2008?
Provide a short and direct response. 0.75. What is the ratio of the Value added (constant 2005 US$) of Timor-Leste in 2006 to that in 2008?
Make the answer very short. 0.33. What is the ratio of the Value added (constant 2005 US$) of Cuba in 2006 to that in 2009?
Keep it short and to the point. 0.91. What is the ratio of the Value added (constant 2005 US$) of Germany in 2006 to that in 2009?
Keep it short and to the point. 1.13. What is the ratio of the Value added (constant 2005 US$) in Montenegro in 2006 to that in 2009?
Provide a succinct answer. 0.92. What is the ratio of the Value added (constant 2005 US$) in Timor-Leste in 2006 to that in 2009?
Make the answer very short. 0.23. What is the ratio of the Value added (constant 2005 US$) in Cuba in 2007 to that in 2008?
Offer a very short reply. 0.95. What is the ratio of the Value added (constant 2005 US$) in Germany in 2007 to that in 2008?
Your response must be concise. 1.01. What is the ratio of the Value added (constant 2005 US$) of Montenegro in 2007 to that in 2008?
Keep it short and to the point. 0.83. What is the ratio of the Value added (constant 2005 US$) in Timor-Leste in 2007 to that in 2008?
Provide a succinct answer. 0.49. What is the ratio of the Value added (constant 2005 US$) of Cuba in 2007 to that in 2009?
Your answer should be very brief. 0.95. What is the ratio of the Value added (constant 2005 US$) in Germany in 2007 to that in 2009?
Provide a short and direct response. 1.17. What is the ratio of the Value added (constant 2005 US$) of Montenegro in 2007 to that in 2009?
Your answer should be compact. 1.02. What is the ratio of the Value added (constant 2005 US$) in Timor-Leste in 2007 to that in 2009?
Ensure brevity in your answer.  0.35. What is the ratio of the Value added (constant 2005 US$) in Cuba in 2008 to that in 2009?
Keep it short and to the point. 1. What is the ratio of the Value added (constant 2005 US$) in Germany in 2008 to that in 2009?
Keep it short and to the point. 1.16. What is the ratio of the Value added (constant 2005 US$) in Montenegro in 2008 to that in 2009?
Your response must be concise. 1.22. What is the ratio of the Value added (constant 2005 US$) of Timor-Leste in 2008 to that in 2009?
Offer a very short reply. 0.71. What is the difference between the highest and the second highest Value added (constant 2005 US$) in Cuba?
Provide a succinct answer. 5.67e+06. What is the difference between the highest and the second highest Value added (constant 2005 US$) of Germany?
Keep it short and to the point. 9.68e+09. What is the difference between the highest and the second highest Value added (constant 2005 US$) of Montenegro?
Provide a succinct answer. 1.05e+08. What is the difference between the highest and the second highest Value added (constant 2005 US$) of Timor-Leste?
Offer a terse response. 3.86e+07. What is the difference between the highest and the lowest Value added (constant 2005 US$) in Cuba?
Offer a terse response. 1.93e+09. What is the difference between the highest and the lowest Value added (constant 2005 US$) in Germany?
Make the answer very short. 1.21e+11. What is the difference between the highest and the lowest Value added (constant 2005 US$) of Montenegro?
Offer a terse response. 2.31e+08. What is the difference between the highest and the lowest Value added (constant 2005 US$) of Timor-Leste?
Your response must be concise. 1.02e+08. 